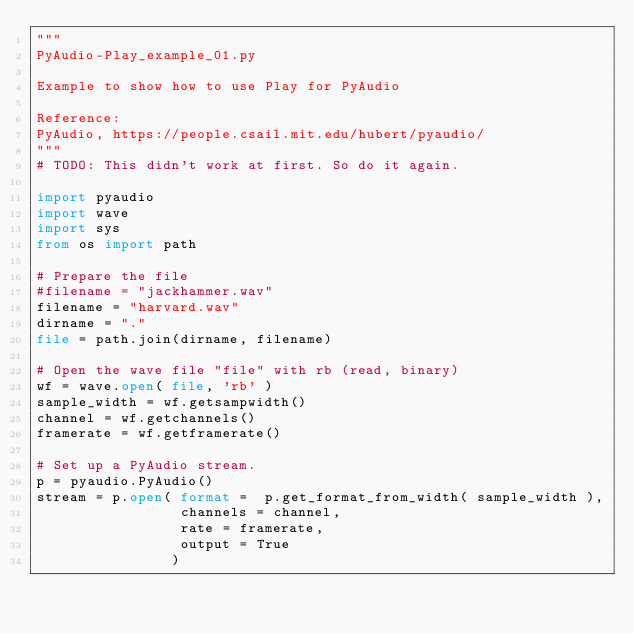<code> <loc_0><loc_0><loc_500><loc_500><_Python_>"""
PyAudio-Play_example_01.py

Example to show how to use Play for PyAudio

Reference:
PyAudio, https://people.csail.mit.edu/hubert/pyaudio/
"""
# TODO: This didn't work at first. So do it again.

import pyaudio
import wave
import sys
from os import path

# Prepare the file
#filename = "jackhammer.wav"
filename = "harvard.wav"
dirname = "."
file = path.join(dirname, filename)

# Open the wave file "file" with rb (read, binary)
wf = wave.open( file, 'rb' )
sample_width = wf.getsampwidth()
channel = wf.getchannels()
framerate = wf.getframerate()

# Set up a PyAudio stream.
p = pyaudio.PyAudio()
stream = p.open( format =  p.get_format_from_width( sample_width ),
                 channels = channel,
                 rate = framerate,
                 output = True
                )
</code> 